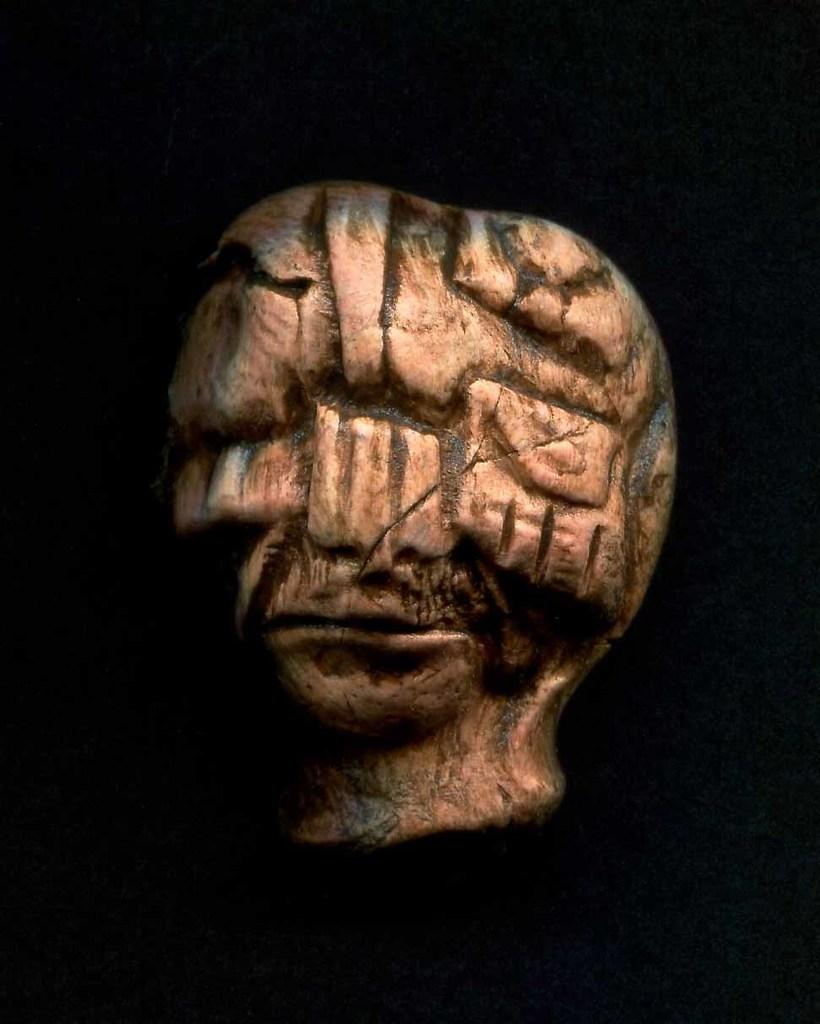What is the main subject in the image? There is an object in the image. What can be observed about the background of the image? The background of the image is dark. What type of treatment is being administered to the object in the image? There is no indication in the image that any treatment is being administered to the object. Is the object in the image wearing a crown? There is no crown visible on the object in the image. Is the object in the image located on an island? There is no information about the object's location in relation to an island in the image. 